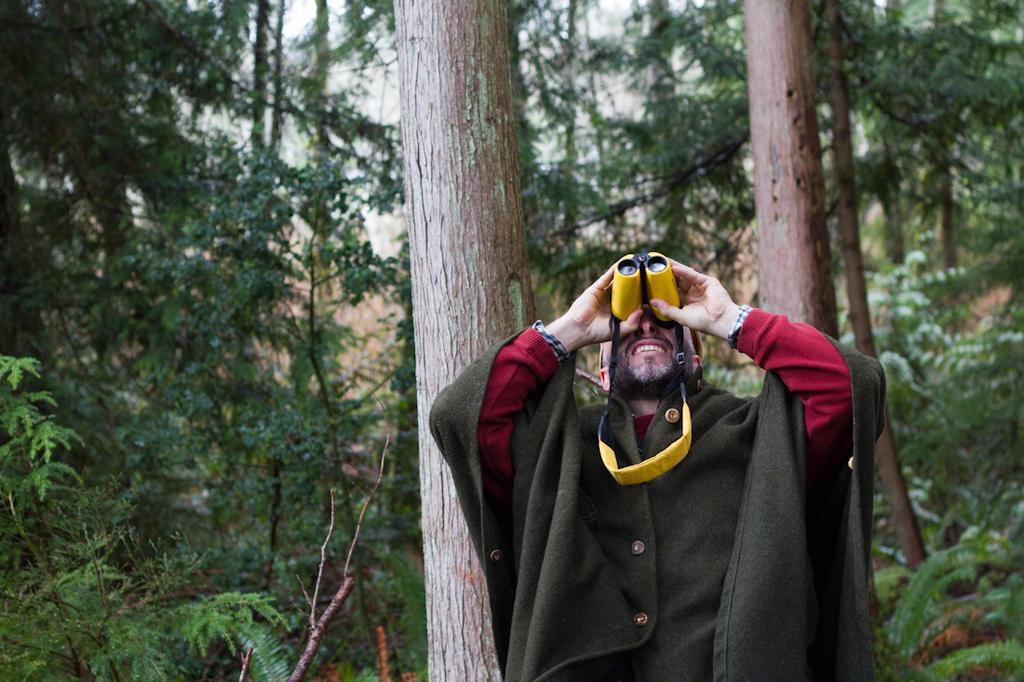In one or two sentences, can you explain what this image depicts? In this picture I can see a man holding a binocular and I can see trees in the background and a cloudy sky. 